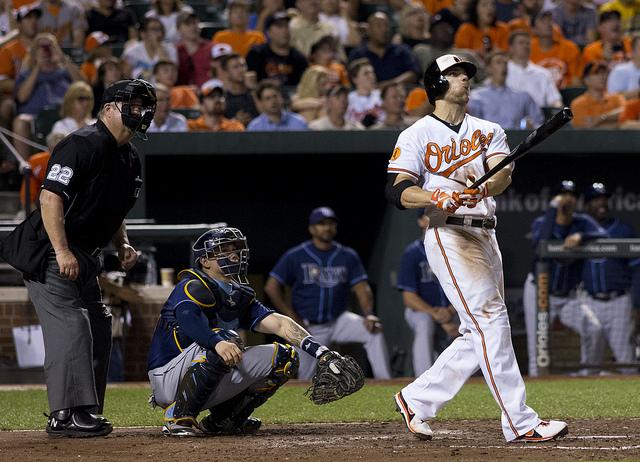What number is the ump?
Quick response, please. 22. Which team is at bat?
Keep it brief. Orioles. What is the job of the man facing right?
Keep it brief. Batter. What color is the bat?
Keep it brief. Black. What is the color of the uniforms?
Keep it brief. White and orange. 